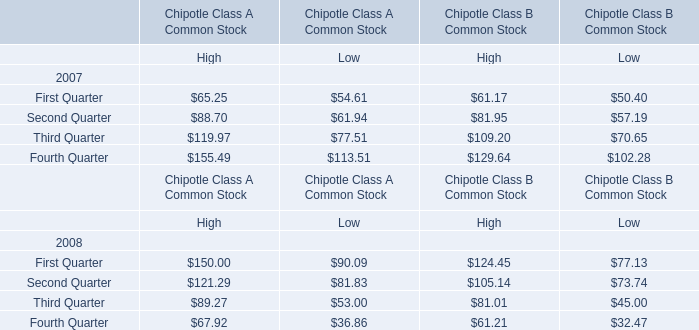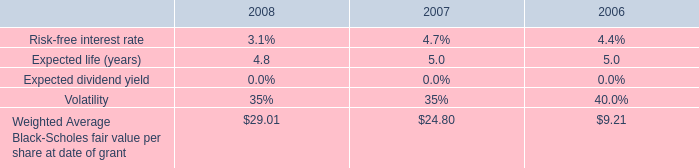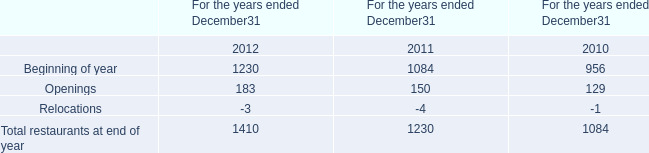Which year is High of First Quarter in terms of Chipotle Class A Common Stock greater than 100 ? 
Answer: 2008. 